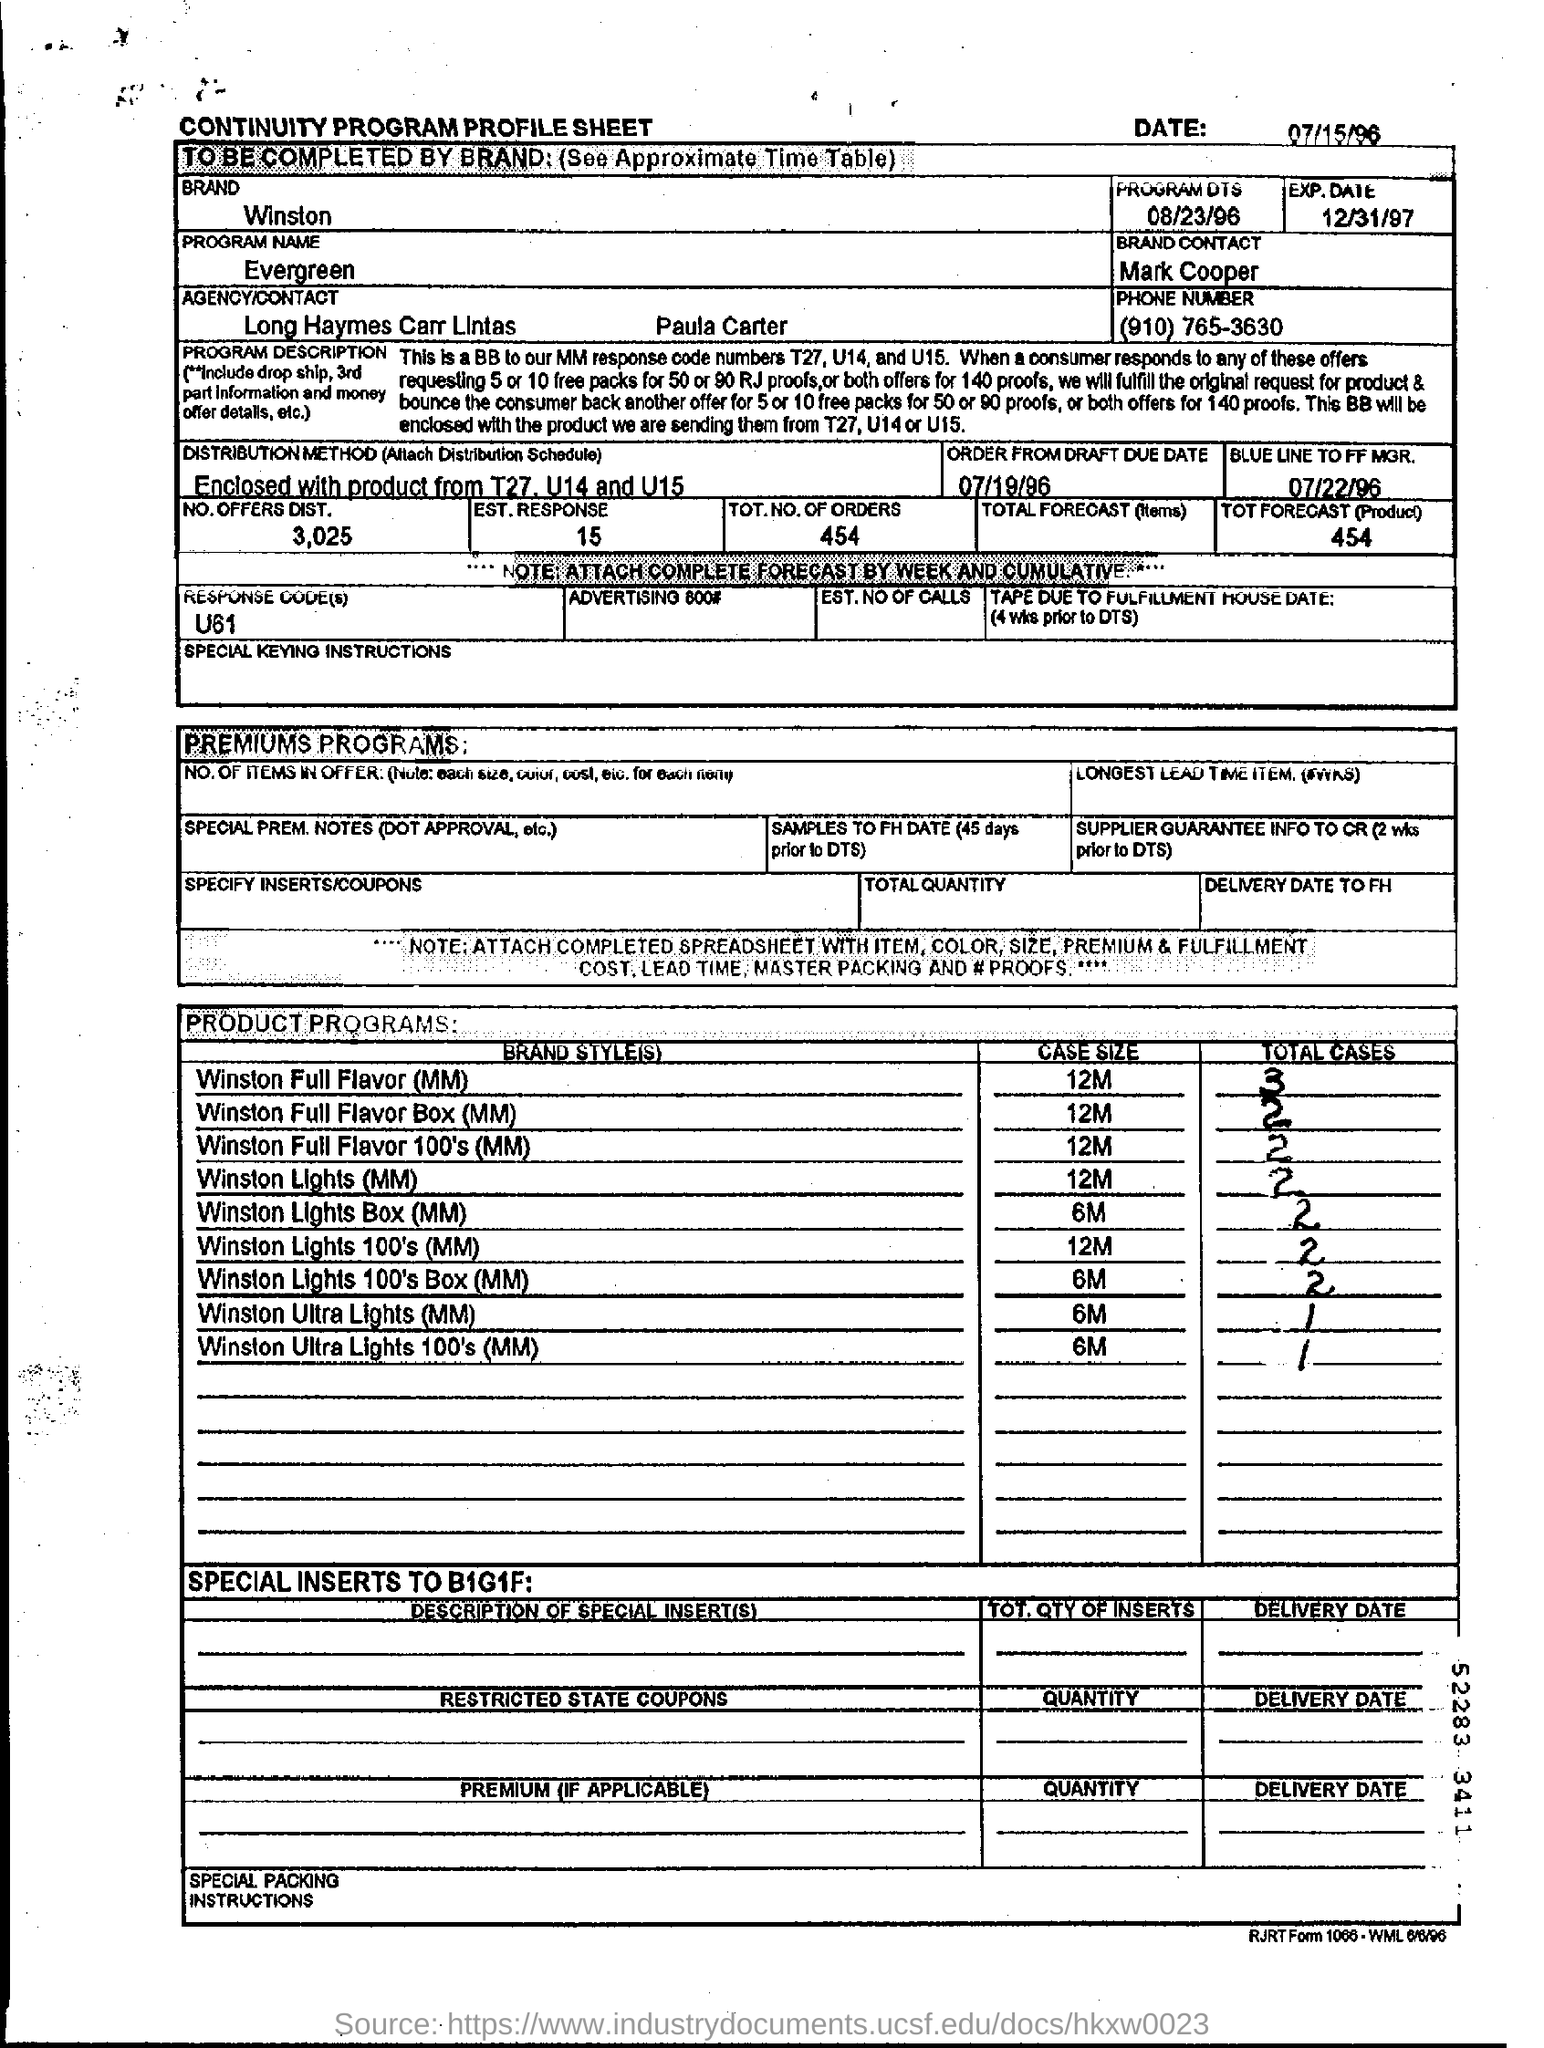Give some essential details in this illustration. The total number of orders is 454. The case size of Winston Lights (MM) is 12 millimeters. The program name is Evergreen. The response code assigned is U61. 